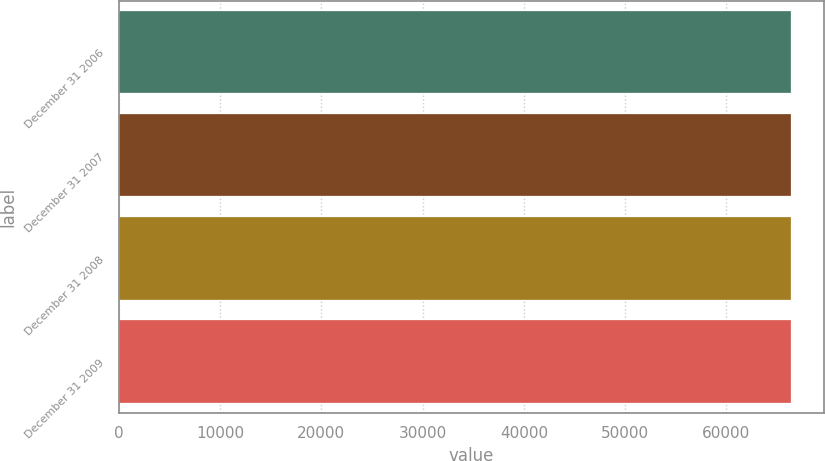Convert chart to OTSL. <chart><loc_0><loc_0><loc_500><loc_500><bar_chart><fcel>December 31 2006<fcel>December 31 2007<fcel>December 31 2008<fcel>December 31 2009<nl><fcel>66368<fcel>66368.1<fcel>66368.2<fcel>66368.3<nl></chart> 